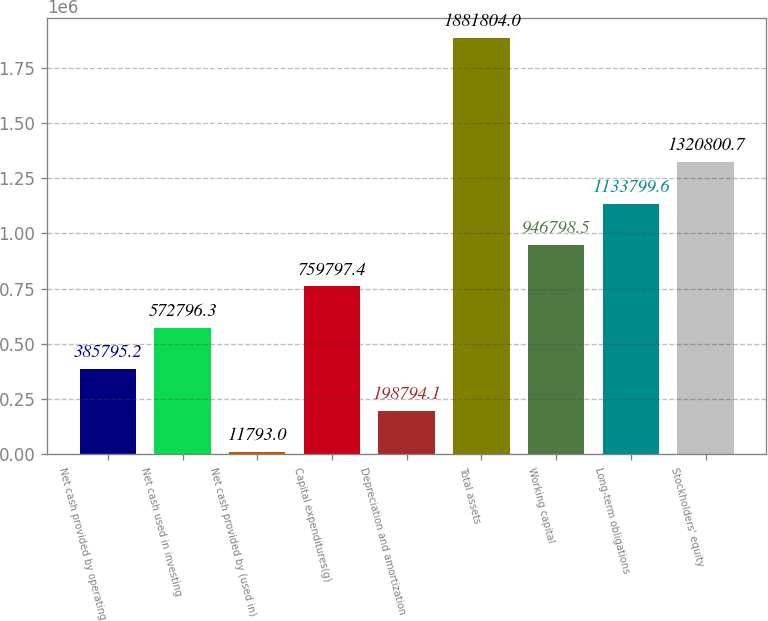Convert chart. <chart><loc_0><loc_0><loc_500><loc_500><bar_chart><fcel>Net cash provided by operating<fcel>Net cash used in investing<fcel>Net cash provided by (used in)<fcel>Capital expenditures(g)<fcel>Depreciation and amortization<fcel>Total assets<fcel>Working capital<fcel>Long-term obligations<fcel>Stockholders' equity<nl><fcel>385795<fcel>572796<fcel>11793<fcel>759797<fcel>198794<fcel>1.8818e+06<fcel>946798<fcel>1.1338e+06<fcel>1.3208e+06<nl></chart> 